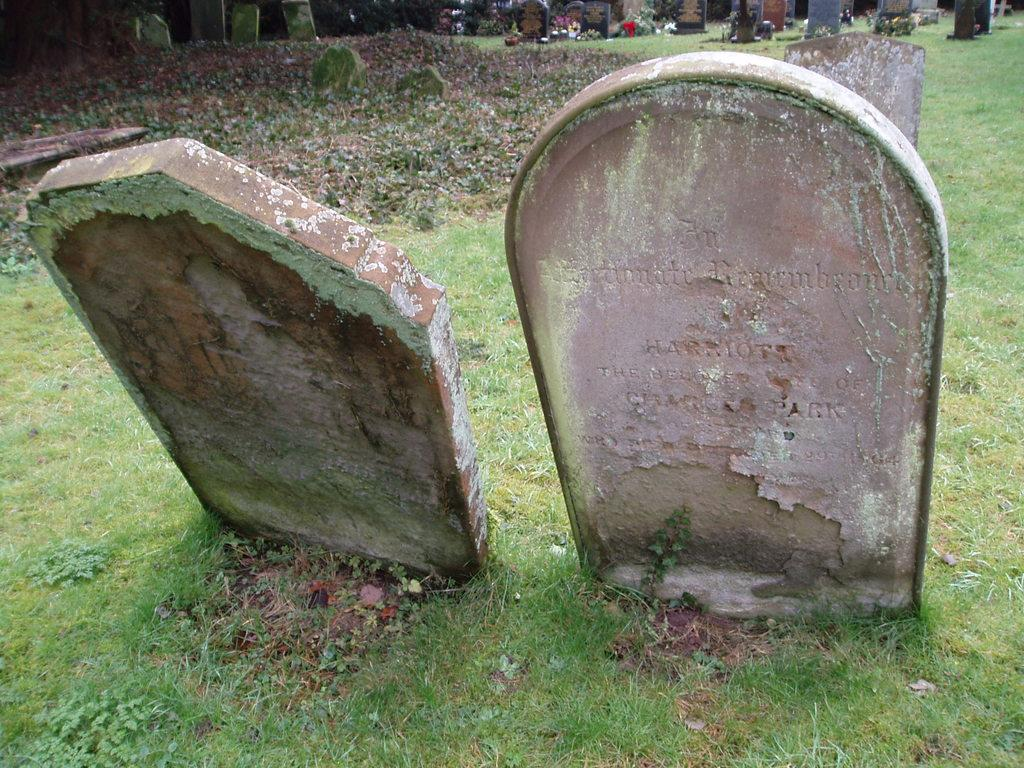What can be seen in the image? There are two headstones in the image. Where are the headstones located? The headstones are on a greenery ground. Are there any other headstones visible in the image? Yes, there are other headstones in the background of the image. What type of whip is being used to prepare a feast in the image? There is no whip or feast present in the image; it features two headstones on a greenery ground. What tool is being used to hammer the headstones in the image? There is no hammer or hammering activity depicted in the image; the headstones are already in place on the greenery ground. 